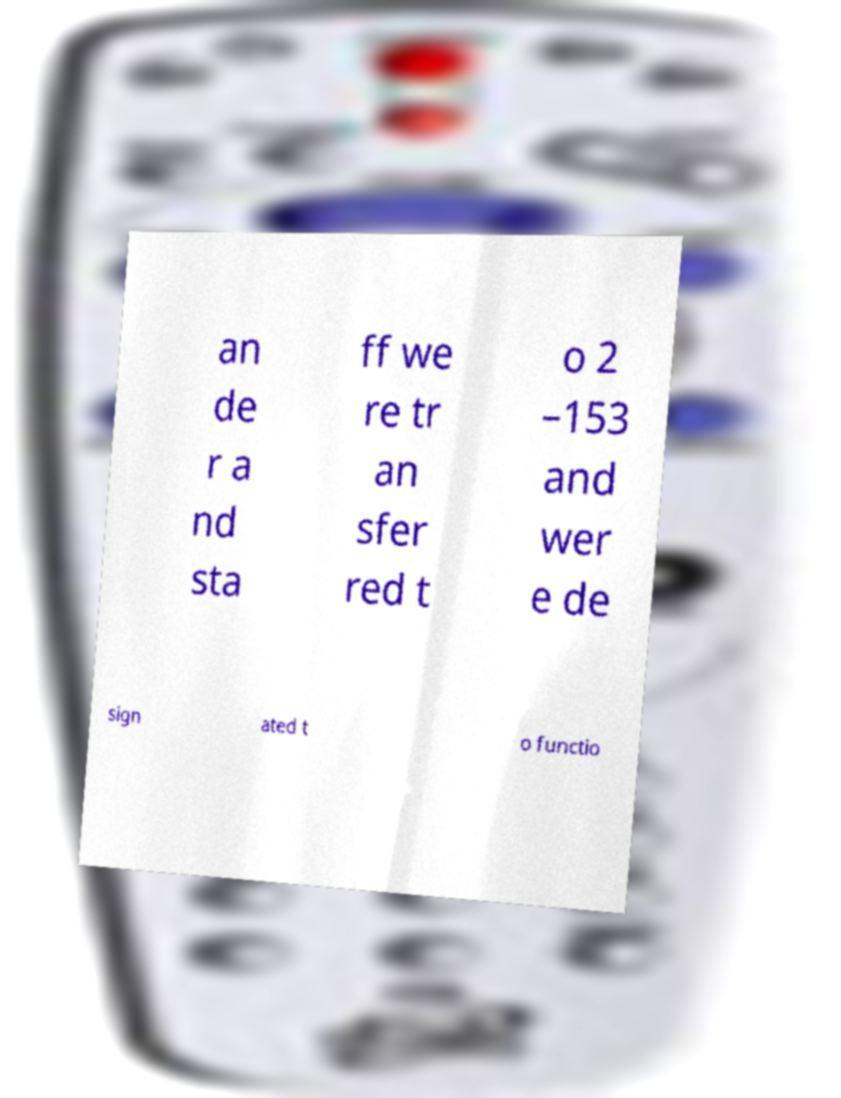Could you assist in decoding the text presented in this image and type it out clearly? an de r a nd sta ff we re tr an sfer red t o 2 –153 and wer e de sign ated t o functio 